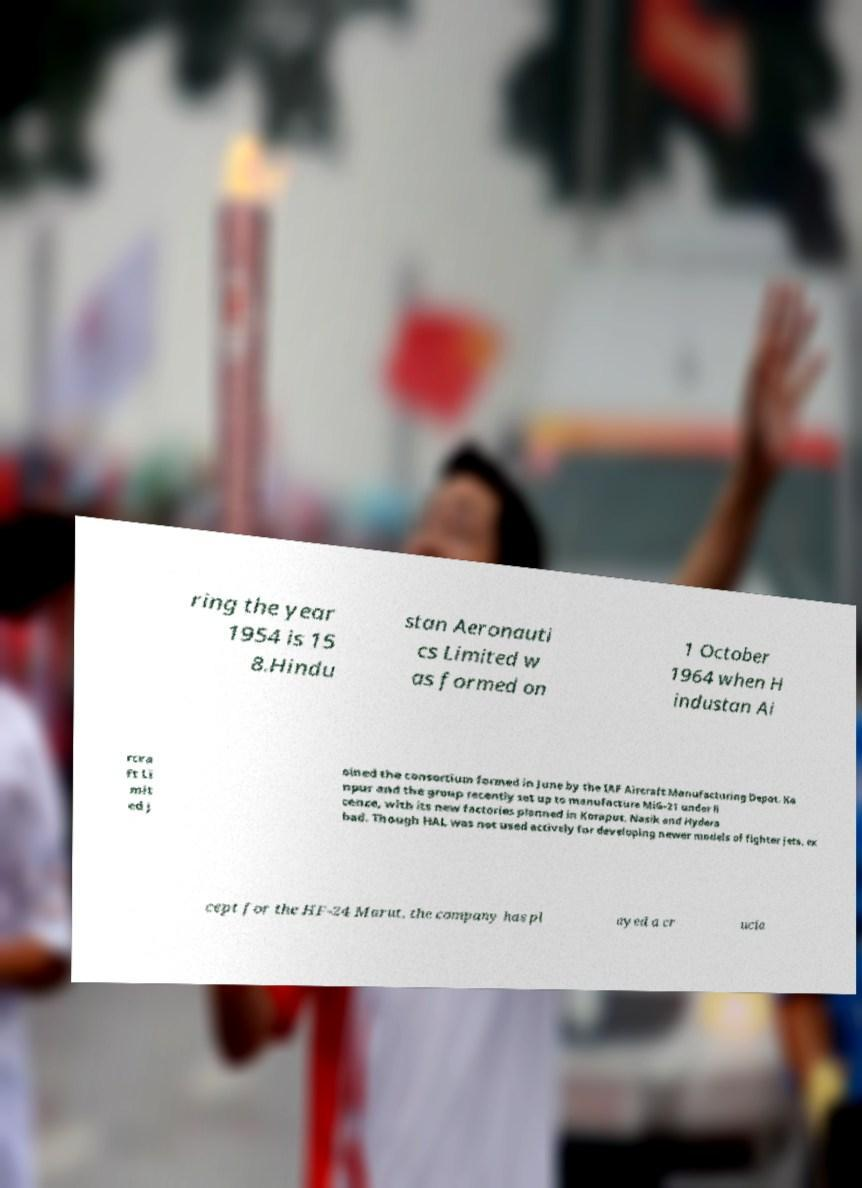Can you accurately transcribe the text from the provided image for me? ring the year 1954 is 15 8.Hindu stan Aeronauti cs Limited w as formed on 1 October 1964 when H industan Ai rcra ft Li mit ed j oined the consortium formed in June by the IAF Aircraft Manufacturing Depot, Ka npur and the group recently set up to manufacture MiG-21 under li cence, with its new factories planned in Koraput, Nasik and Hydera bad. Though HAL was not used actively for developing newer models of fighter jets, ex cept for the HF-24 Marut, the company has pl ayed a cr ucia 